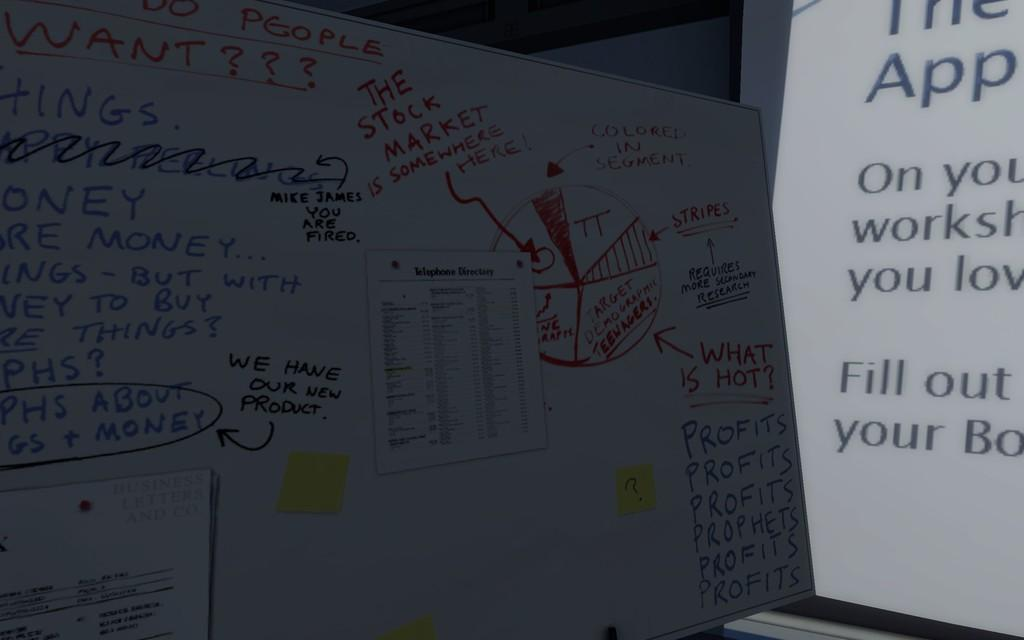<image>
Render a clear and concise summary of the photo. A whiteboard covered in writing and scribbles with the words "We have our new product!" written in the center. 